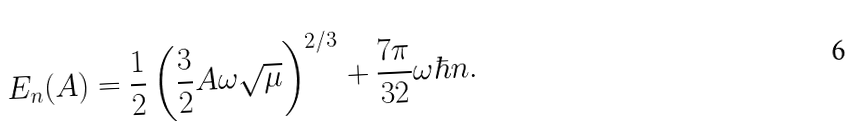<formula> <loc_0><loc_0><loc_500><loc_500>E _ { n } ( A ) = \frac { 1 } { 2 } \left ( \frac { 3 } { 2 } A \omega \sqrt { \mu } \right ) ^ { 2 / 3 } + \frac { 7 \pi } { 3 2 } \omega \hbar { n } .</formula> 